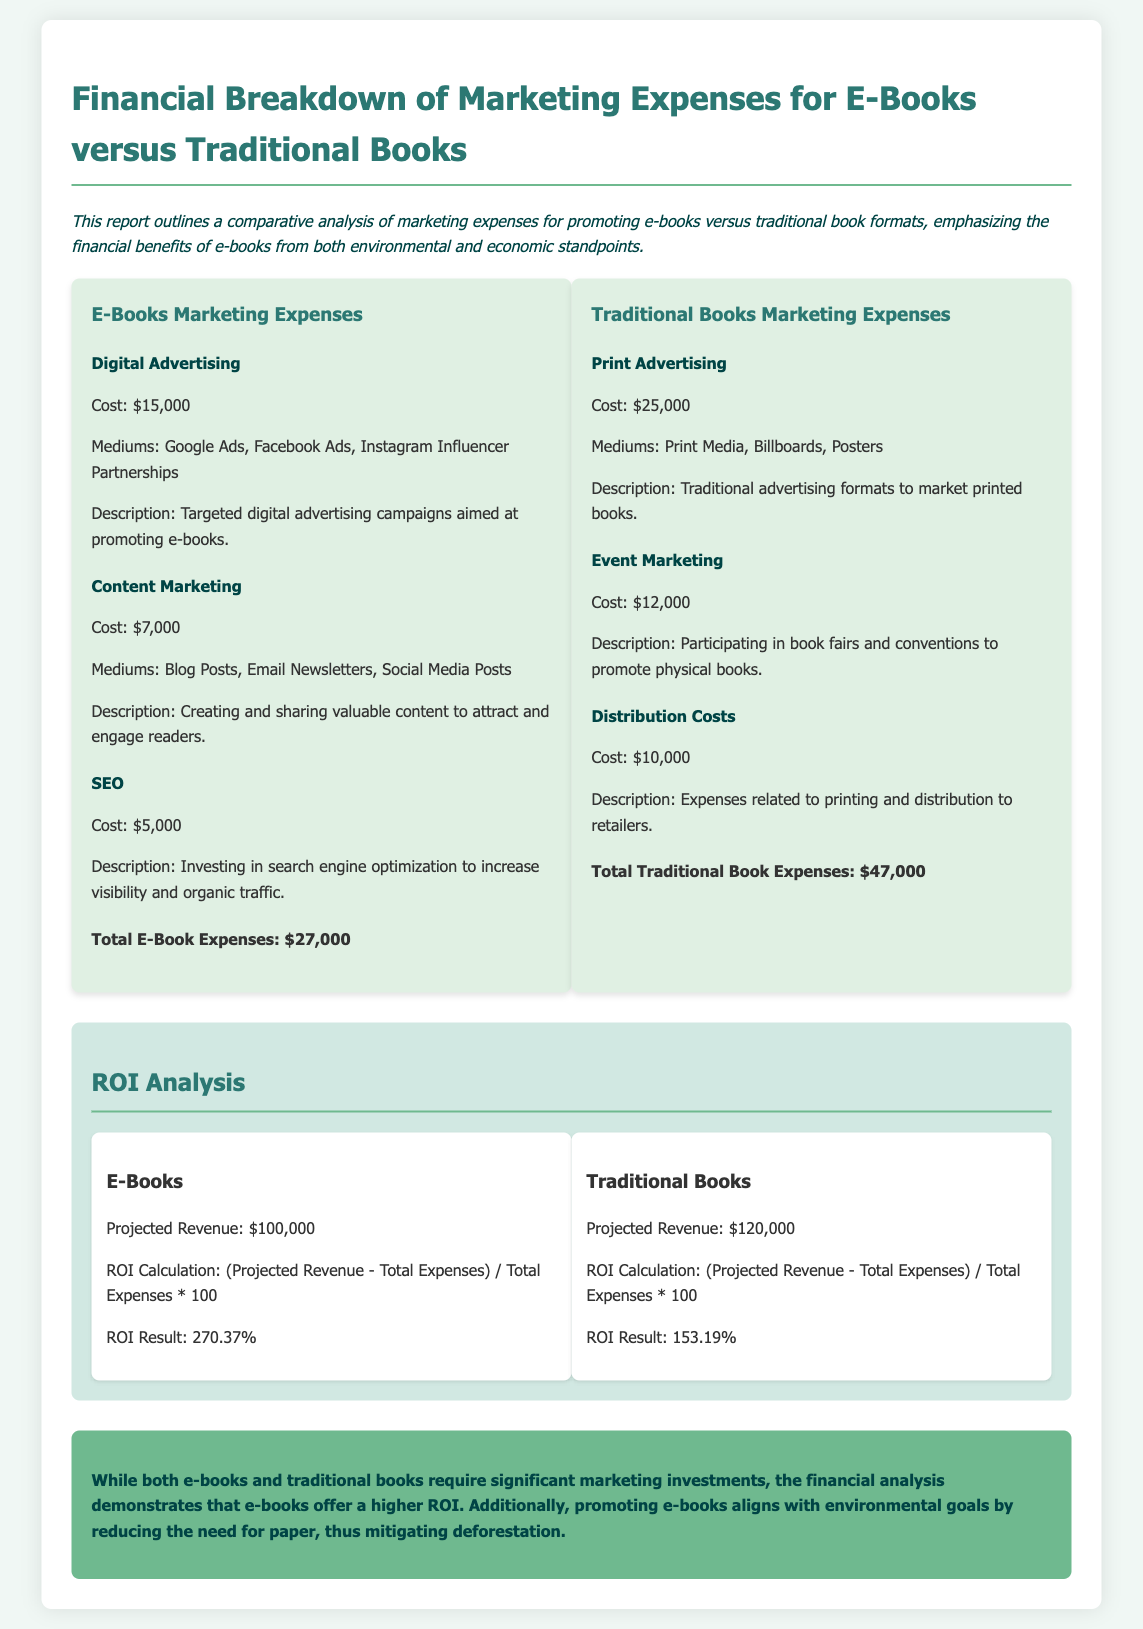What are the total E-Book marketing expenses? The total E-Book marketing expenses are detailed in the expense comparison section.
Answer: $27,000 What is the cost of Digital Advertising for E-Books? The document specifies the cost of Digital Advertising under E-Books Marketing Expenses.
Answer: $15,000 What is the projected revenue for Traditional Books? The projected revenue for Traditional Books is given in the ROI analysis section.
Answer: $120,000 What is the ROI result for E-Books? The ROI result for E-Books is calculated and presented in the ROI analysis section.
Answer: 270.37% Which marketing strategy has a lower total expense? This question overlaps with financial analysis comparing E-Books and Traditional Books.
Answer: E-Books What is the cost of Print Advertising for Traditional Books? The document provides the cost of Print Advertising in the Traditional Books marketing expenses section.
Answer: $25,000 What is the cost attributed to SEO for E-Books? The cost attributed to SEO for E-Books is presented in the E-Books Marketing Expenses section.
Answer: $5,000 What is the conclusion regarding the financial analysis of e-books? The conclusion summarizes the findings of the financial analysis related to e-books and traditional books.
Answer: Higher ROI and environmental benefits 